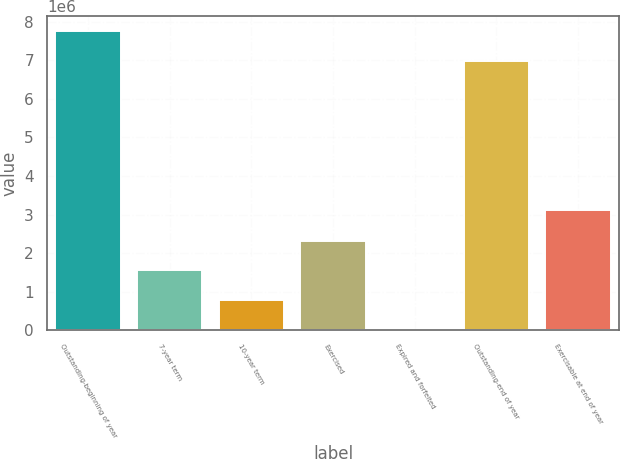Convert chart to OTSL. <chart><loc_0><loc_0><loc_500><loc_500><bar_chart><fcel>Outstanding-beginning of year<fcel>7-year term<fcel>10-year term<fcel>Exercised<fcel>Expired and forfeited<fcel>Outstanding-end of year<fcel>Exercisable at end of year<nl><fcel>7.74622e+06<fcel>1.55378e+06<fcel>781150<fcel>2.32641e+06<fcel>8518<fcel>6.97359e+06<fcel>3.11585e+06<nl></chart> 